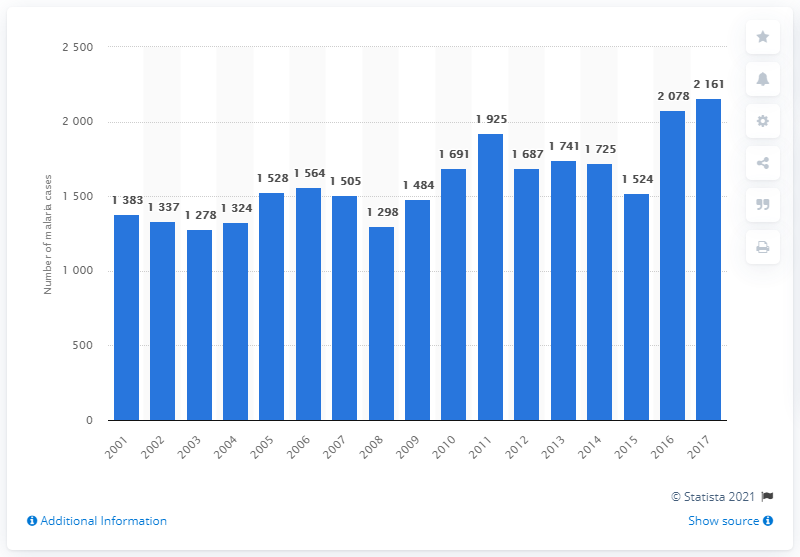Indicate a few pertinent items in this graphic. The United States experienced a rise in Malaria cases in the year 2001. 